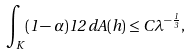Convert formula to latex. <formula><loc_0><loc_0><loc_500><loc_500>\int _ { K } ( 1 - \alpha ) ^ { } { 1 } 2 \, d A ( h ) \leq C \lambda ^ { - \frac { 1 } { 3 } } ,</formula> 